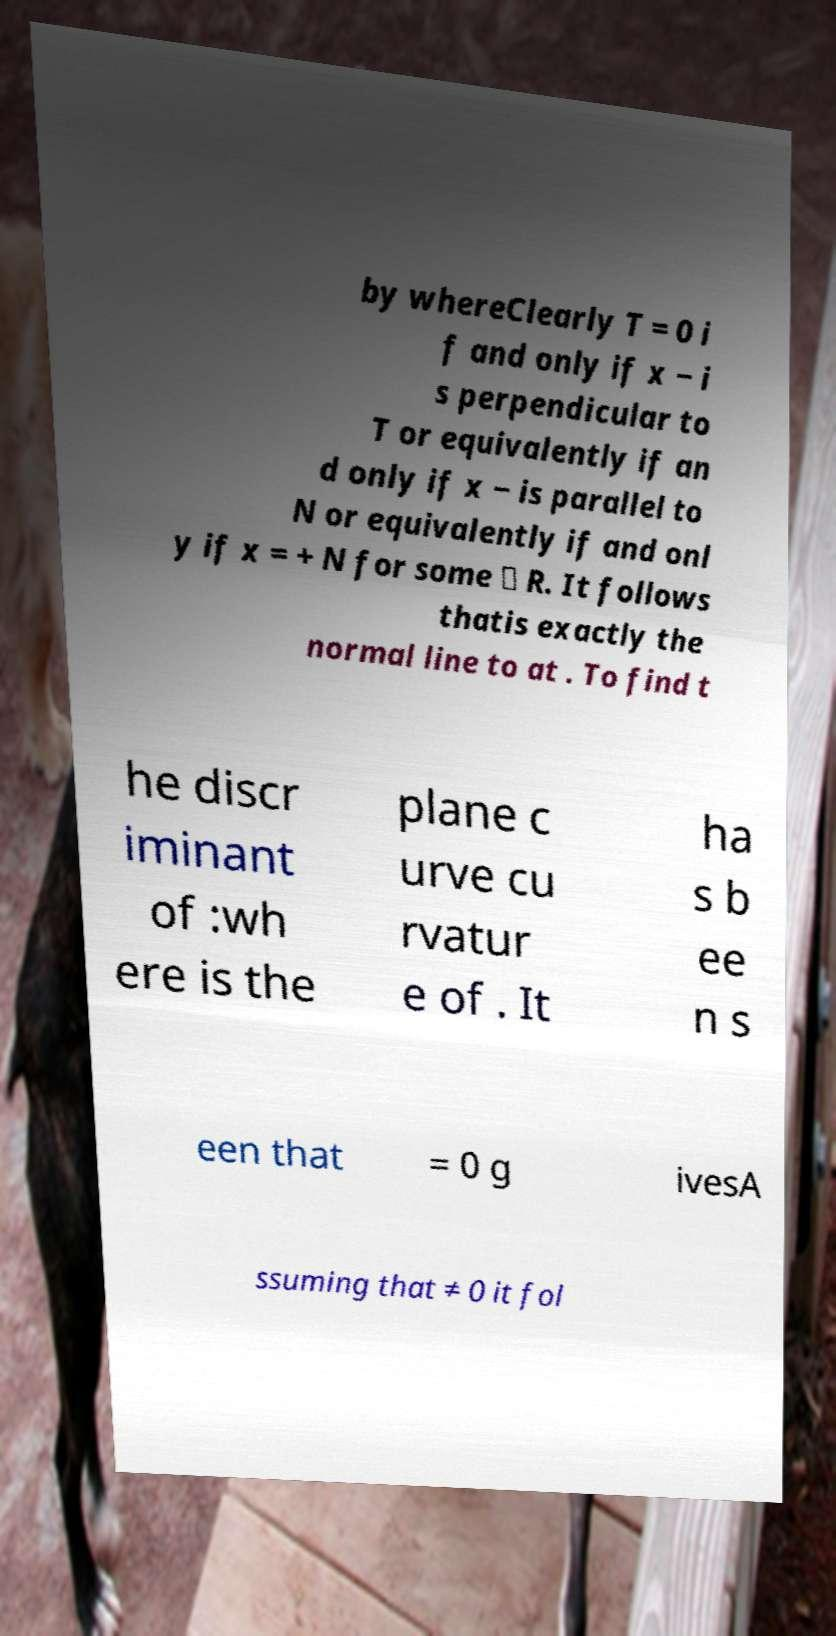There's text embedded in this image that I need extracted. Can you transcribe it verbatim? by whereClearly T = 0 i f and only if x − i s perpendicular to T or equivalently if an d only if x − is parallel to N or equivalently if and onl y if x = + N for some ∈ R. It follows thatis exactly the normal line to at . To find t he discr iminant of :wh ere is the plane c urve cu rvatur e of . It ha s b ee n s een that = 0 g ivesA ssuming that ≠ 0 it fol 